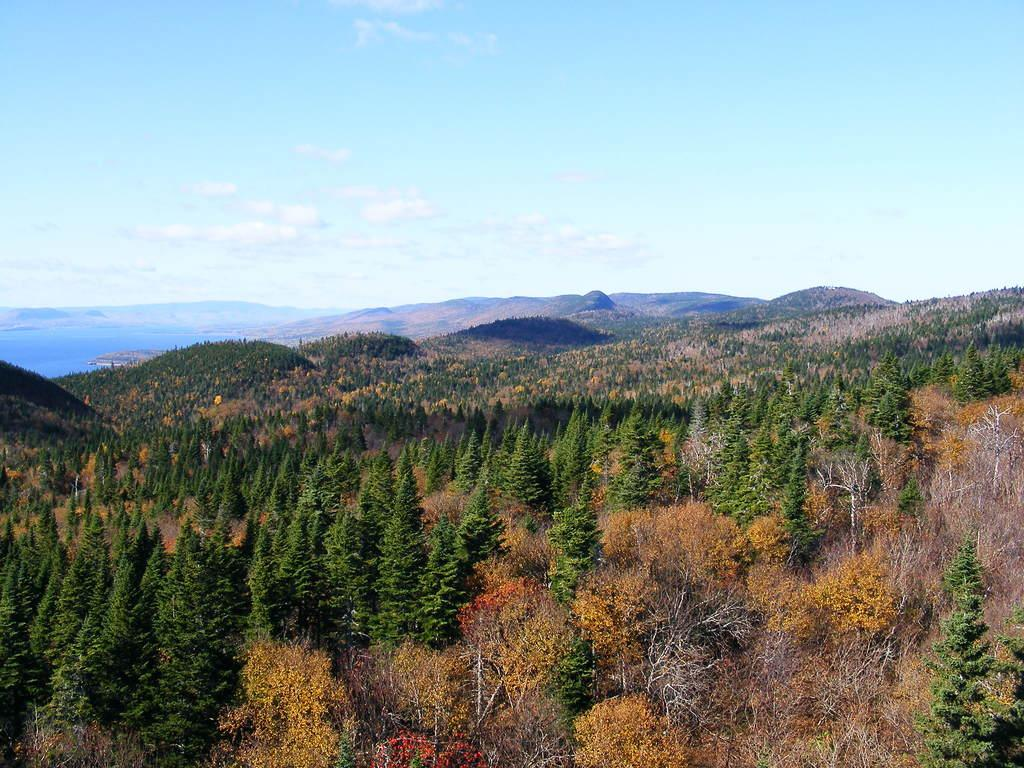What type of vegetation can be seen in the image? The image contains trees. What colors are the trees in the image? Some trees are orange in color, and some are yellow in color. What geographical features can be seen in the image? A: There are hills visible in the image. What is visible in the sky in the image? The sky is visible in the image, and clouds are present. How many spiders can be seen crawling on the trees in the image? There are no spiders visible in the image; it only features trees, hills, and clouds. What type of teeth can be seen on the trees in the image? Trees do not have teeth, so there are no teeth visible in the image. 